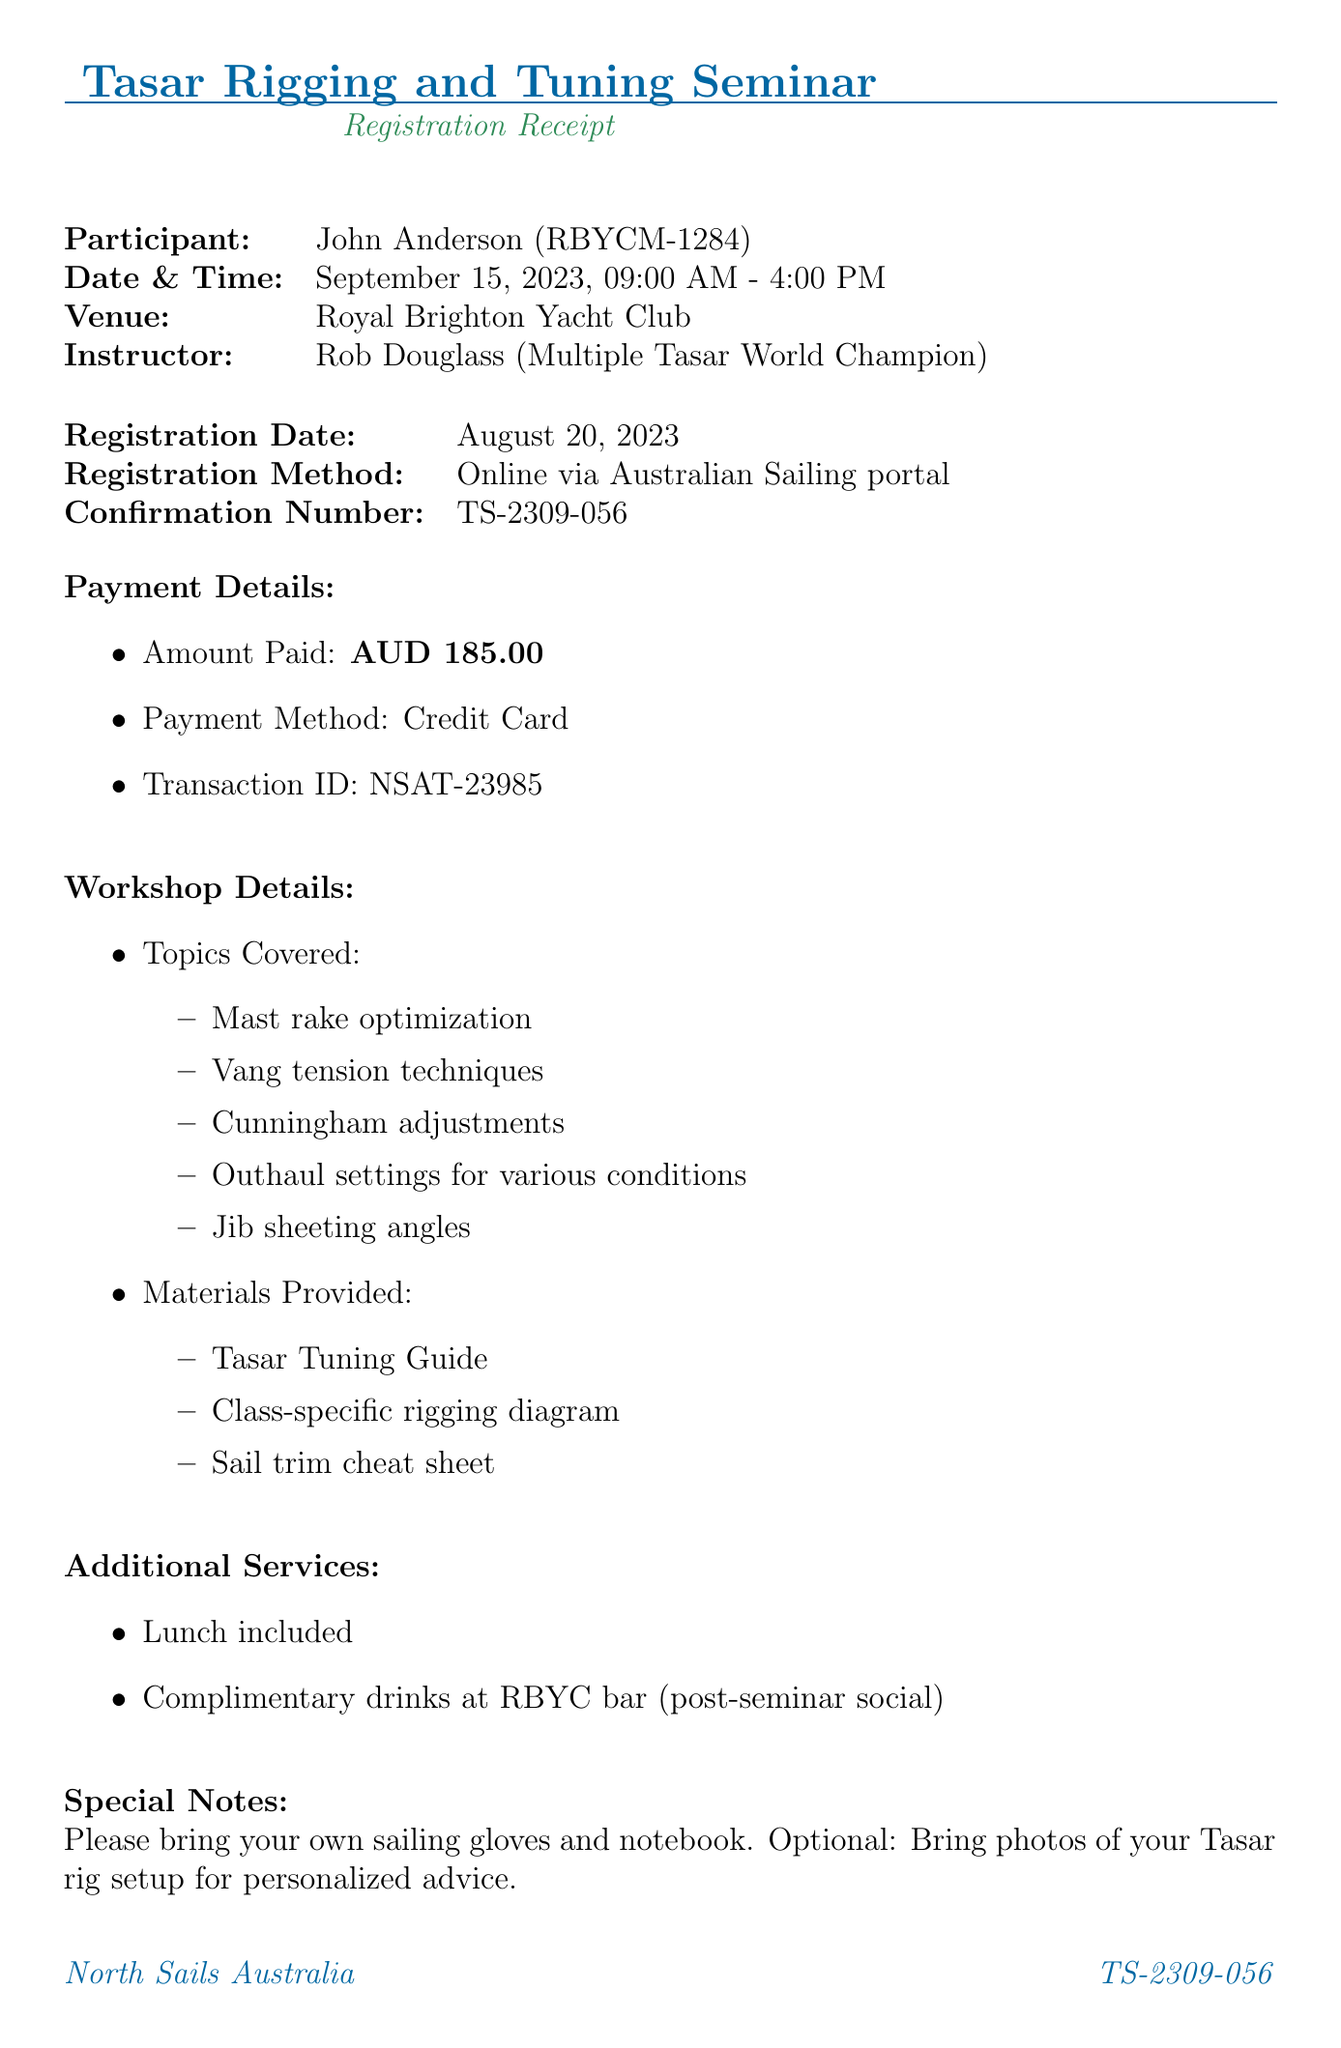What is the name of the seminar? The event name is explicitly stated in the document.
Answer: Tasar Rigging and Tuning Seminar Who is the instructor of the workshop? The document mentions the name and credentials of the instructor.
Answer: Rob Douglass What is the venue for the seminar? The venue is clearly listed in the details of the document.
Answer: Royal Brighton Yacht Club What date is the seminar scheduled for? The date for the event is provided in the document.
Answer: September 15, 2023 What is the amount paid for registration? The payment details section outlines the registration fee.
Answer: AUD 185.00 What are participants advised to bring? Special notes section lists items that participants should bring.
Answer: Sailing gloves and notebook How many topics are covered in the workshop? The topics covered are listed in a bullet-point format.
Answer: Five What is the cancellation policy for the seminar? The cancellation policy is directly stated in the document.
Answer: Full refund available up to 7 days before the event Is lunch included in the registration? The additional services section specifies whether lunch is included.
Answer: Yes 